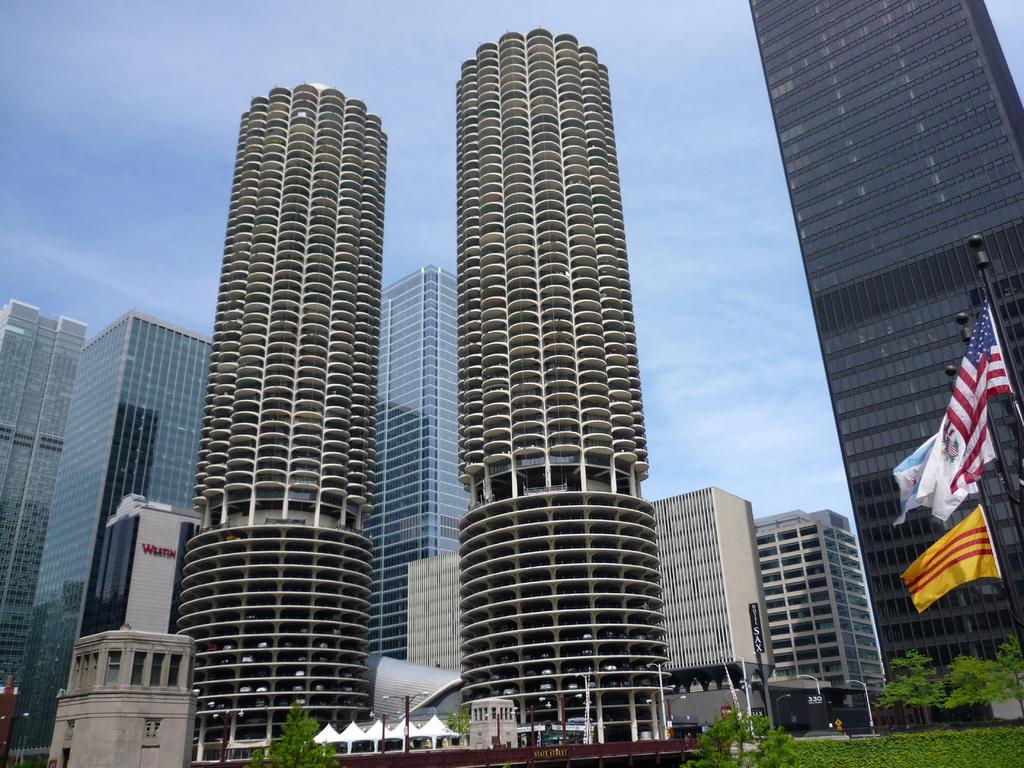Please provide a concise description of this image. In the picture we can see some tower buildings with many floors and near it, we can see two cylindrical shaped buildings and near it, we can see some trees, plants, poles and in the background we can see the sky with clouds. 